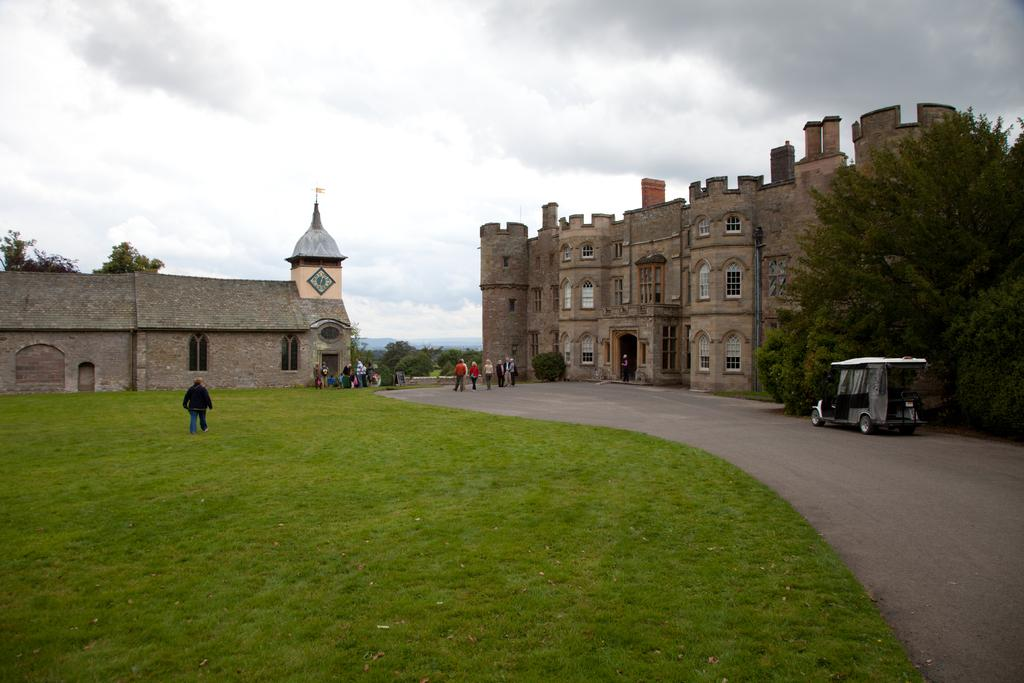What type of structures can be seen in the image? There are buildings in the image. What natural elements are present in the image? There are trees and grass in the image. What type of transportation is visible in the image? There is a vehicle in the image. Are there any living beings in the image? Yes, there are people in the image. What part of the natural environment is visible in the image? The sky is visible in the image. What atmospheric conditions can be observed in the sky? Clouds are present in the sky. What type of jeans is the tree wearing in the image? There are no jeans present in the image, as trees are not capable of wearing clothing. What song is being sung by the clouds in the image? There is no song being sung by the clouds in the image, as clouds are not capable of singing. 